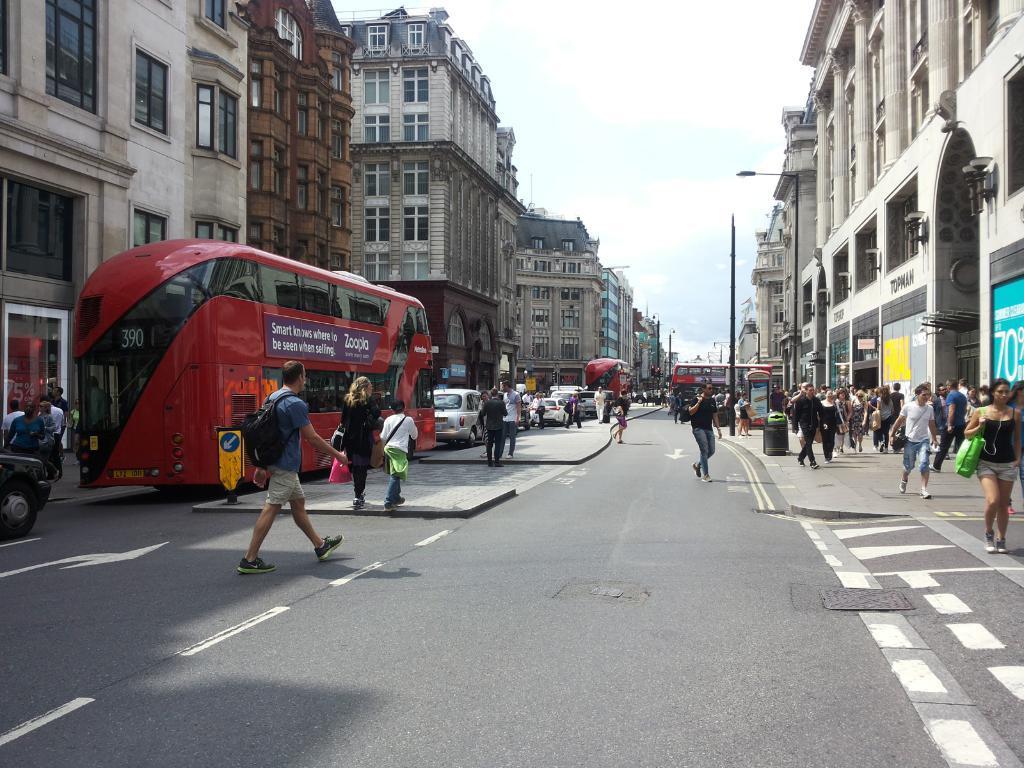How would you summarize this image in a sentence or two? In the image there is a road and there are a lot of people moving around the road, there is a footpath on the right side and there are few vehicles on the left side, around the road there are many buildings. 